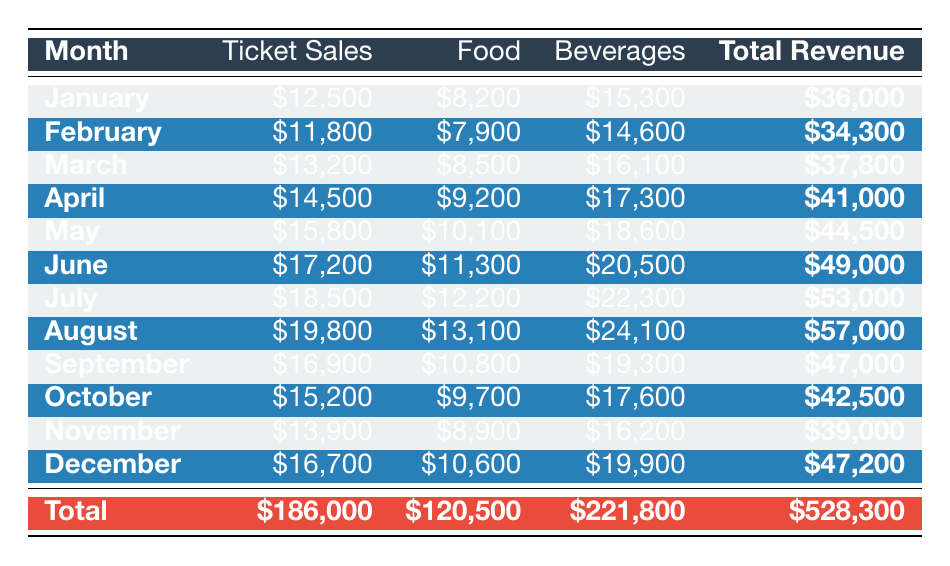What was the total revenue in December? The table shows the total revenue for December listed in the last row. It is clearly stated as $47,200.
Answer: $47,200 Which month had the highest ticket sales? By reviewing the ticket sales column, the highest amount is found in August at $19,800.
Answer: $19,800 What is the average revenue from food sales over the 12 months? To find the average revenue from food, sum all food sales: $8,200 + $7,900 + $8,500 + $9,200 + $10,100 + $11,300 + $12,200 + $13,100 + $10,800 + $9,700 + $8,900 + $10,600 = $120,500. Then divide that by 12, which gives $120,500 / 12 = $10,041.67, rounded to $10,042.
Answer: $10,042 Did ticket sales exceed $15,000 in more than half of the months? By checking each month's ticket sales, we find that ticket sales exceeded $15,000 in June, July, August, May, and April, totaling 5 months. Since there are 12 months in total, more than half would be 7 months. Therefore, 5 does not exceed half.
Answer: No What is the total revenue from all three categories combined over the year? By examining the total revenue row, it lists $528,300, which is the sum of total revenues combining ticket sales, food, and beverages for each month.
Answer: $528,300 Which month had the lowest sales from food? Looking at the food sales column, the lowest amount is found in February at $7,900.
Answer: $7,900 What was the increase in revenue from beverages from January to August? The beverage sales for January are $15,300 and for August are $24,100. To find the increase, subtract January from August: $24,100 - $15,300 = $8,800.
Answer: $8,800 True or False: April had a higher total revenue than March. By comparing the total revenue values, April's total is $41,000 and March's total is $37,800. Since $41,000 is greater than $37,800, the statement is true.
Answer: True Which month had the closest values in ticket, food, and beverage sales? Upon examining each month's figures, February shows ticket sales of $11,800, food sales of $7,900, and beverage sales of $14,600, which are closer in values than any other month.
Answer: February 